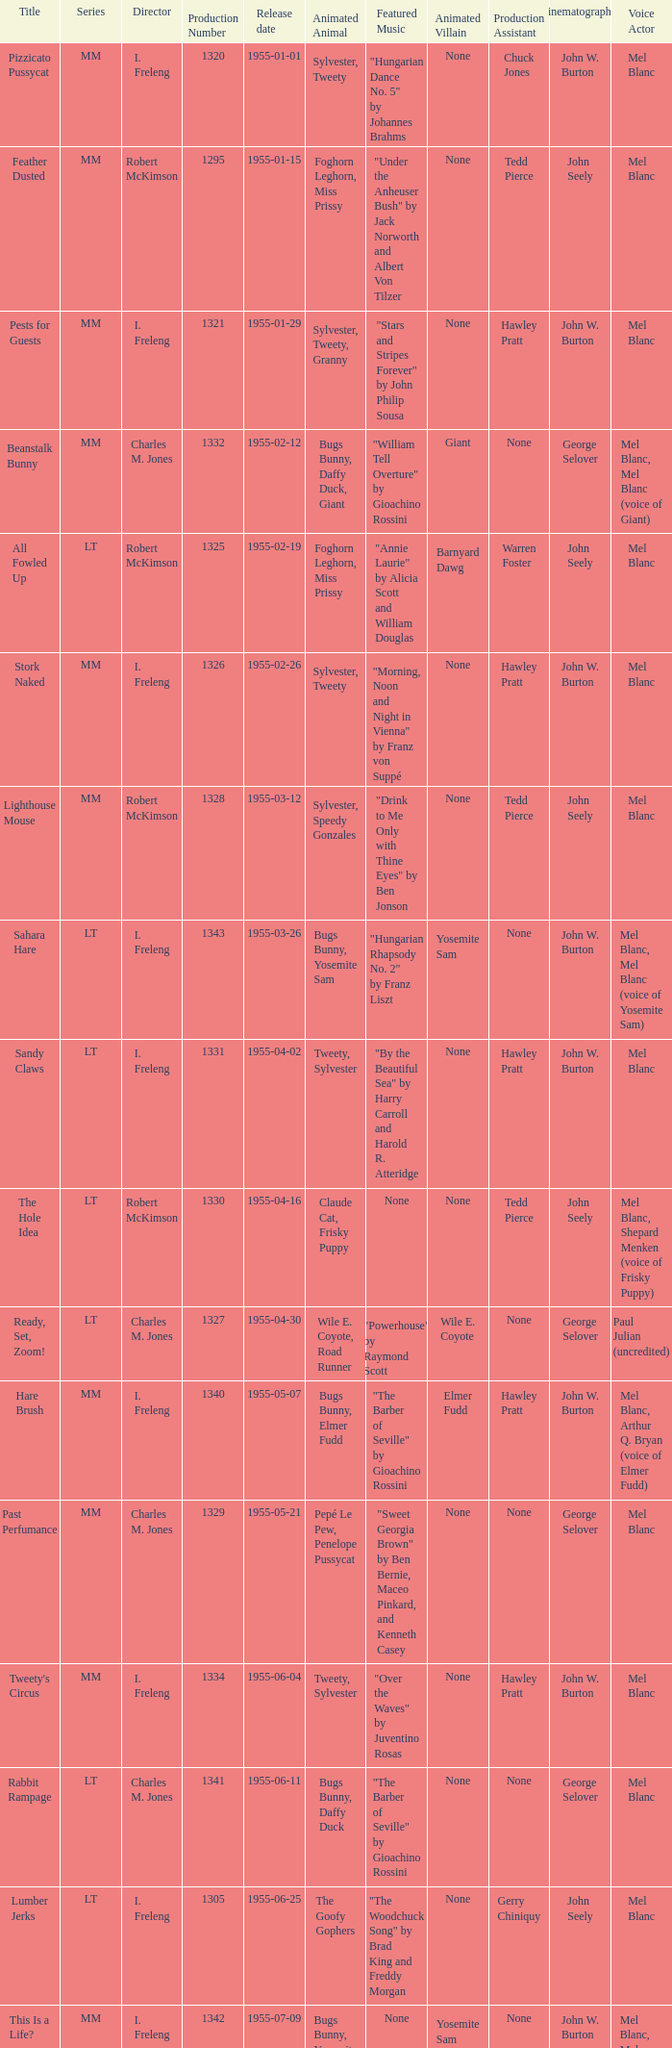What is the highest production number released on 1955-04-02 with i. freleng as the director? 1331.0. 